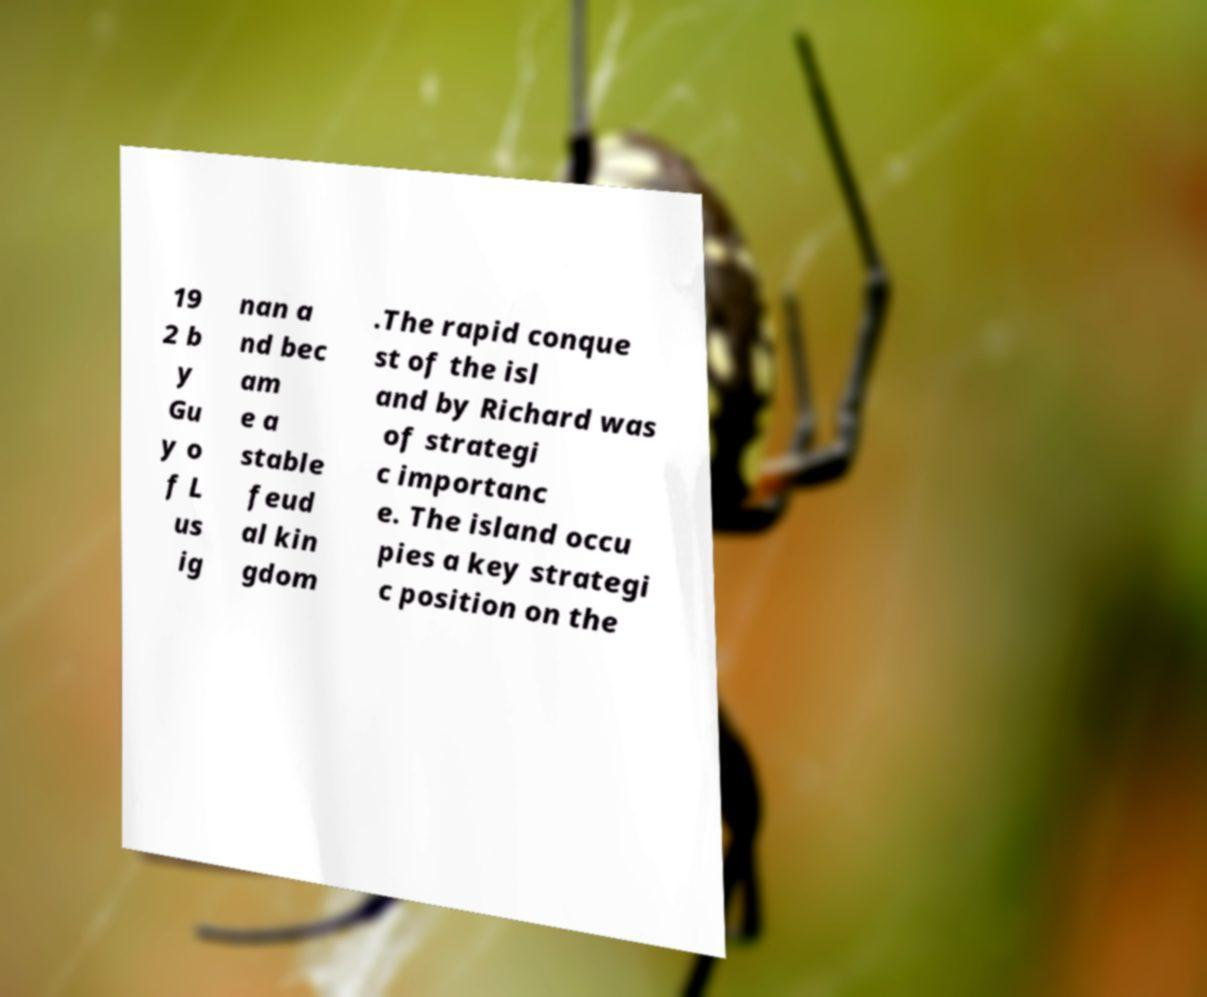Can you read and provide the text displayed in the image?This photo seems to have some interesting text. Can you extract and type it out for me? 19 2 b y Gu y o f L us ig nan a nd bec am e a stable feud al kin gdom .The rapid conque st of the isl and by Richard was of strategi c importanc e. The island occu pies a key strategi c position on the 